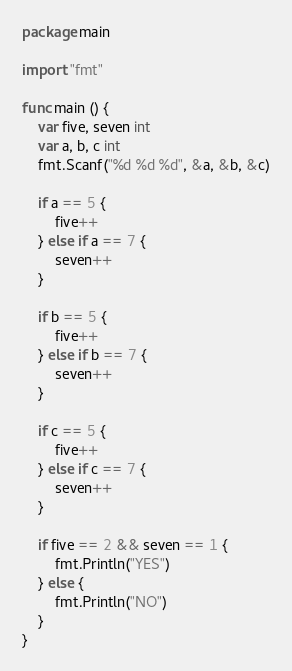<code> <loc_0><loc_0><loc_500><loc_500><_Go_>package main

import "fmt"

func main () {
	var five, seven int
	var a, b, c int
	fmt.Scanf("%d %d %d", &a, &b, &c)
	
	if a == 5 {
		five++
	} else if a == 7 {
		seven++
	}

	if b == 5 {
		five++
	} else if b == 7 {
		seven++
	}

	if c == 5 {
		five++
	} else if c == 7 {
		seven++
	}

	if five == 2 && seven == 1 {
		fmt.Println("YES")
	} else {
		fmt.Println("NO")
	}
}</code> 